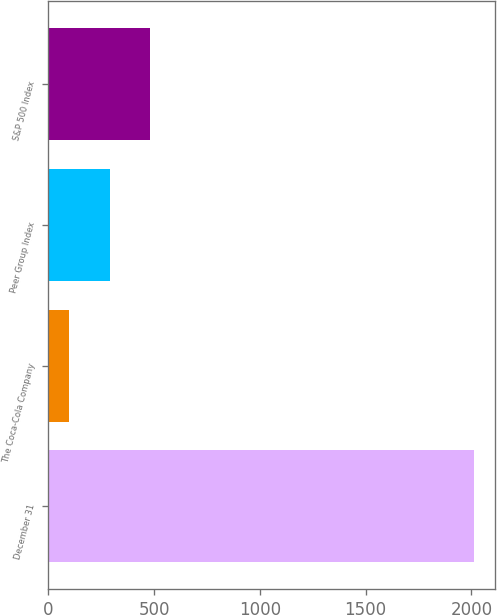Convert chart. <chart><loc_0><loc_0><loc_500><loc_500><bar_chart><fcel>December 31<fcel>The Coca-Cola Company<fcel>Peer Group Index<fcel>S&P 500 Index<nl><fcel>2011<fcel>100<fcel>291.1<fcel>482.2<nl></chart> 